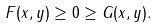<formula> <loc_0><loc_0><loc_500><loc_500>F ( x , y ) \geq 0 \geq G ( x , y ) .</formula> 